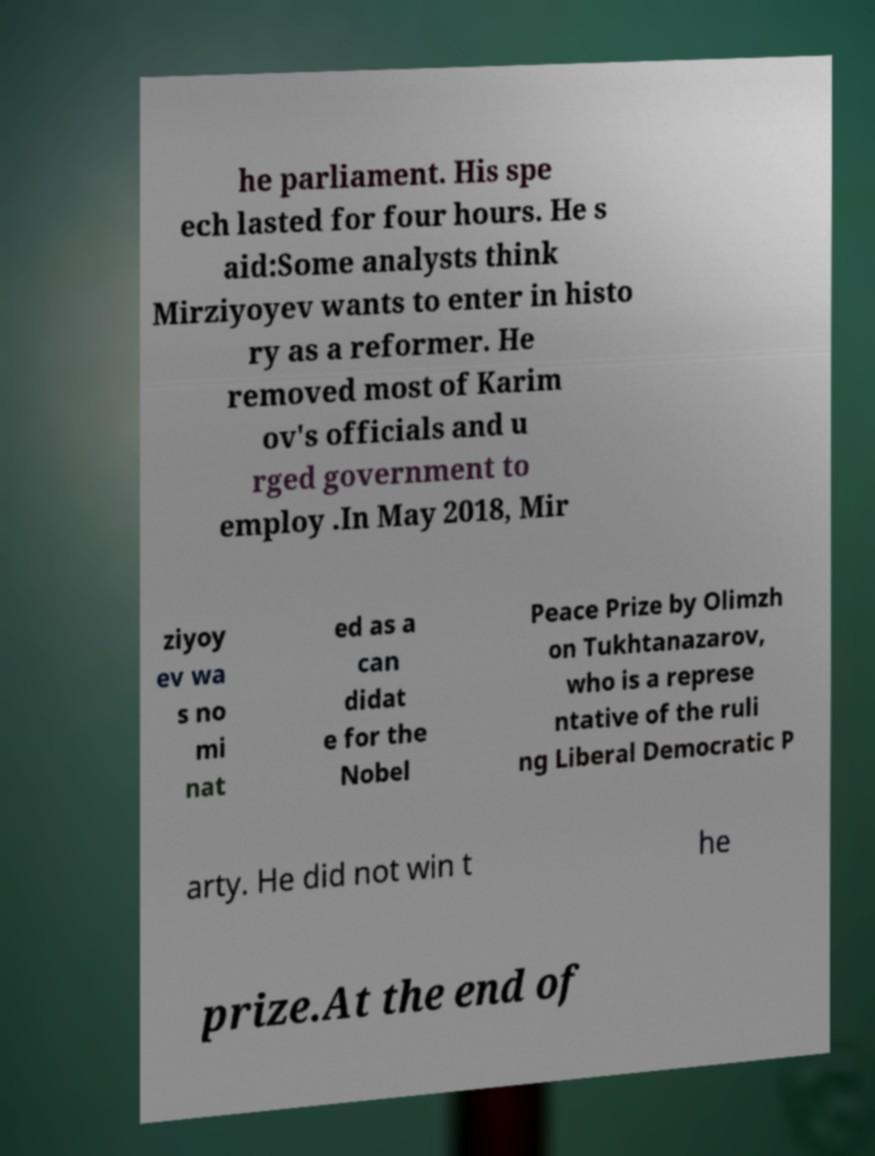I need the written content from this picture converted into text. Can you do that? he parliament. His spe ech lasted for four hours. He s aid:Some analysts think Mirziyoyev wants to enter in histo ry as a reformer. He removed most of Karim ov's officials and u rged government to employ .In May 2018, Mir ziyoy ev wa s no mi nat ed as a can didat e for the Nobel Peace Prize by Olimzh on Tukhtanazarov, who is a represe ntative of the ruli ng Liberal Democratic P arty. He did not win t he prize.At the end of 